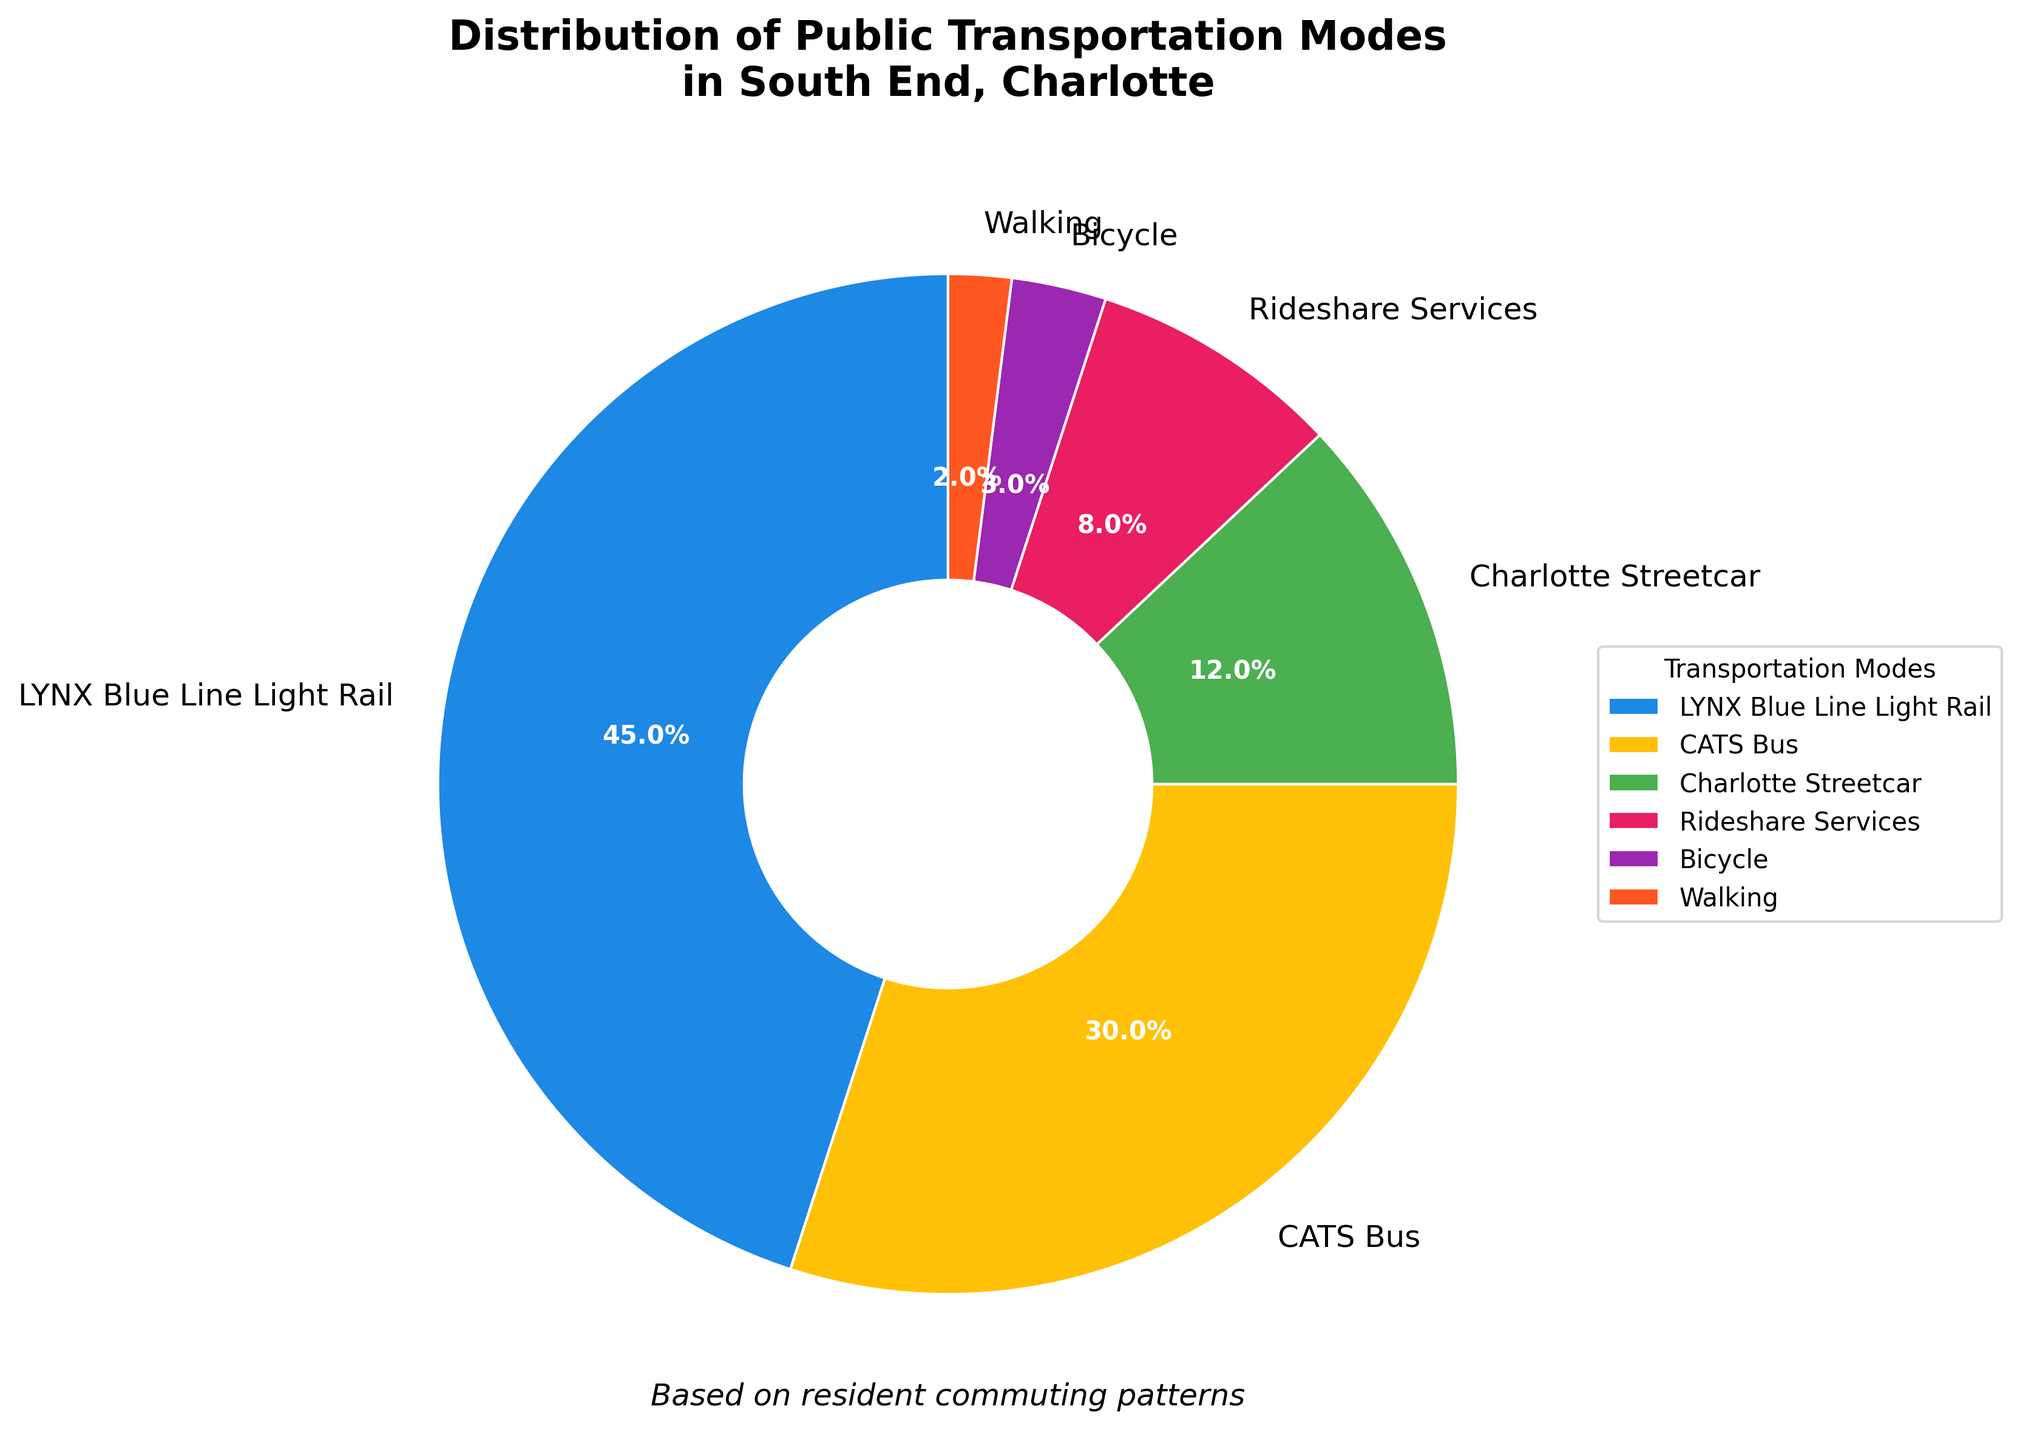What is the most commonly used public transportation mode in South End, Charlotte? The most commonly used mode can be determined by looking at the segment of the pie chart that has the largest percentage. The LYNX Blue Line Light Rail occupies the largest segment with 45%.
Answer: LYNX Blue Line Light Rail What is the combined percentage of residents who use bicycles or walk? To find the combined percentage, sum the percentages for Bicycle and Walking. These are 3% and 2% respectively, so 3% + 2% = 5%.
Answer: 5% Which public transportation mode is used more, the Charlotte Streetcar or Rideshare Services? Compare the percentages of the Charlotte Streetcar and Rideshare Services. The Charlotte Streetcar is used by 12% of residents, while Rideshare Services is used by 8%. 12% is greater than 8%.
Answer: Charlotte Streetcar What percentage of residents use either the CATS Bus or the LYNX Blue Line Light Rail? To find this, add the percentages for the CATS Bus and the LYNX Blue Line Light Rail. The CATS Bus is 30%, and the LYNX Blue Line Light Rail is 45%. 30% + 45% = 75%.
Answer: 75% Is the percentage of residents using the Charlotte Streetcar greater than the sum of those using bicycles and walking? Compare the percentage for Charlotte Streetcar (12%) with the sum of Bicycle (3%) and Walking (2%). 3% + 2% = 5%, and 12% > 5%.
Answer: Yes Which mode of transportation has the smallest share? The smallest share can be identified by looking at the segment of the pie chart with the smallest percentage. Walking has the smallest percentage at 2%.
Answer: Walking What is the difference in percentage between those who use Rideshare Services and those who walk? Find the difference between the percentages for Rideshare Services (8%) and Walking (2%). 8% - 2% = 6%.
Answer: 6% How does the percentage of residents using the CATS Bus compare to those using the Charlotte Streetcar and Bicycle combined? Compare the percentage of CATS Bus (30%) with the sum of Charlotte Streetcar (12%) and Bicycle (3%). 12% + 3% = 15%, and 30% is greater than 15%.
Answer: Greater Are there more residents using the LYNX Blue Line Light Rail or using the CATS Bus and Charlotte Streetcar combined? Compare the percentage of LYNX Blue Line Light Rail (45%) with the sum of CATS Bus (30%) and Charlotte Streetcar (12%). 30% + 12% = 42%, and 45% > 42%.
Answer: LYNX Blue Line Light Rail 